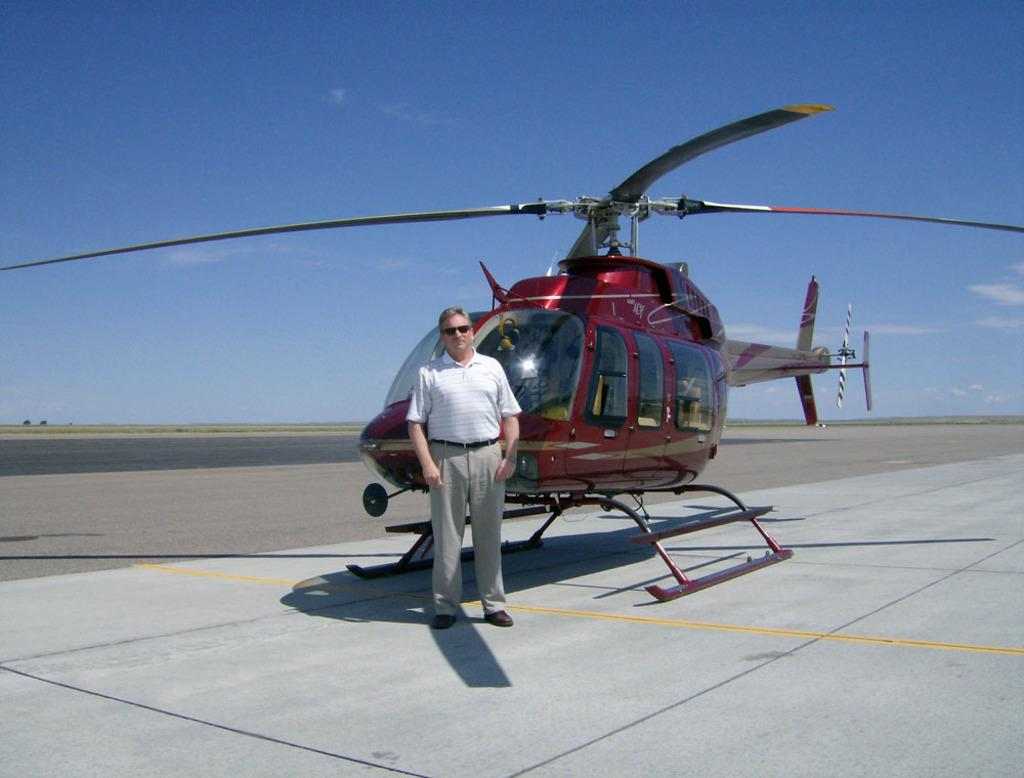What is the main subject in the center of the image? There is a chopper in the center of the image. Can you describe the person in the image? There is a person standing in front of the chopper. What can be seen in the background of the image? The sky is visible in the background of the image. What type of acoustics does the chopper have in the image? There is no information about the acoustics of the chopper in the image. 